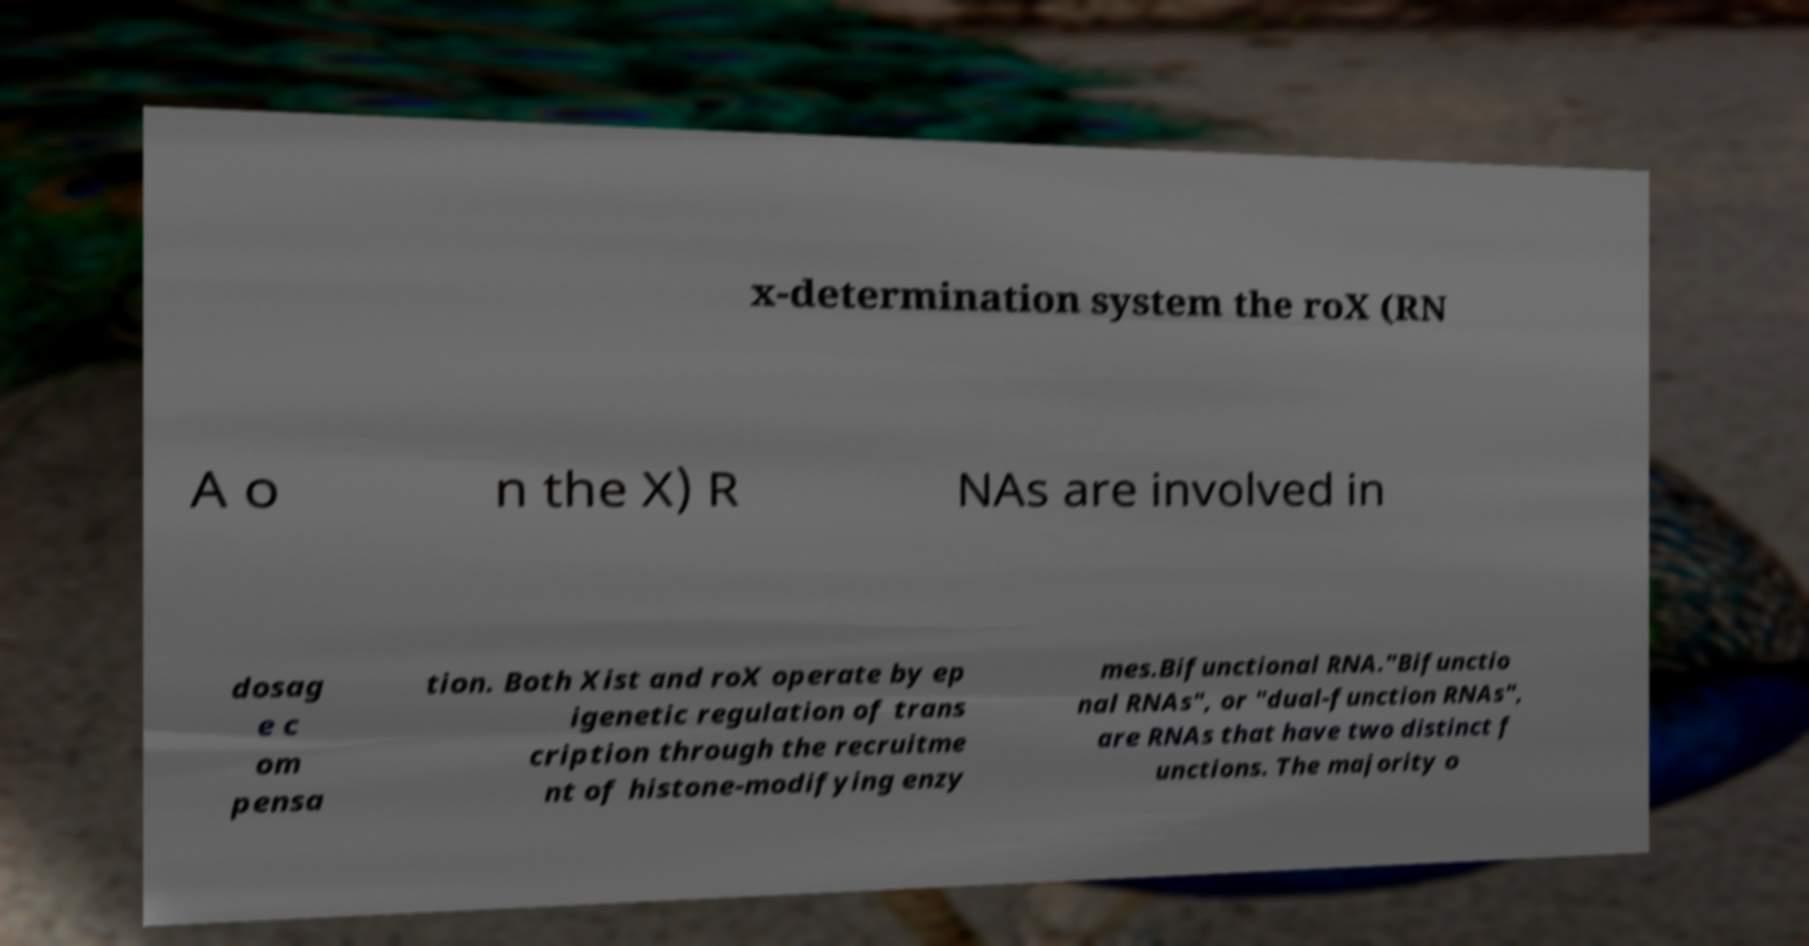Can you read and provide the text displayed in the image?This photo seems to have some interesting text. Can you extract and type it out for me? x-determination system the roX (RN A o n the X) R NAs are involved in dosag e c om pensa tion. Both Xist and roX operate by ep igenetic regulation of trans cription through the recruitme nt of histone-modifying enzy mes.Bifunctional RNA."Bifunctio nal RNAs", or "dual-function RNAs", are RNAs that have two distinct f unctions. The majority o 